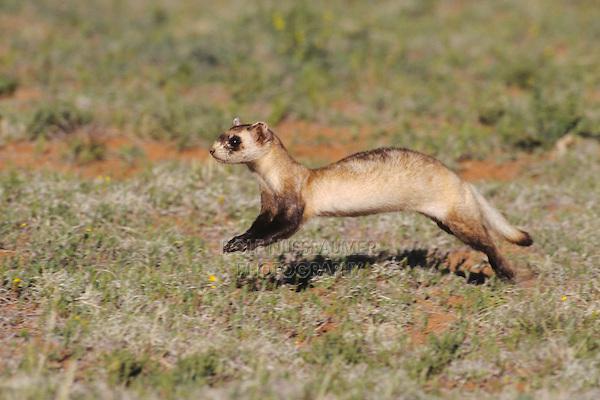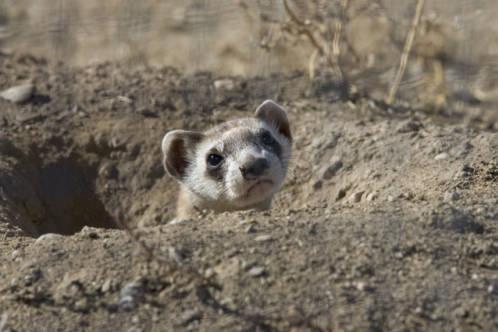The first image is the image on the left, the second image is the image on the right. For the images shown, is this caption "The ferret is seen coming out of a hole in the image on the right." true? Answer yes or no. Yes. The first image is the image on the left, the second image is the image on the right. For the images shown, is this caption "One of the weasels is facing left." true? Answer yes or no. Yes. 